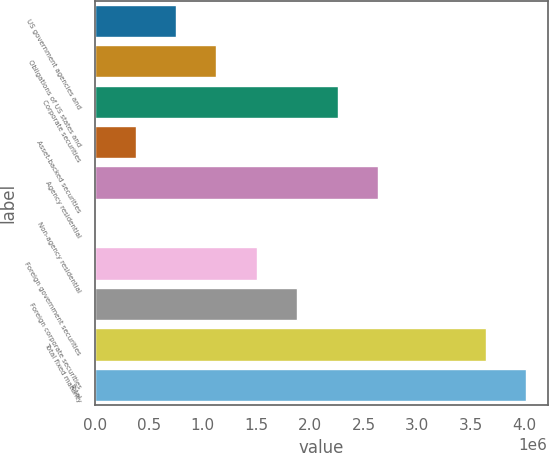<chart> <loc_0><loc_0><loc_500><loc_500><bar_chart><fcel>US government agencies and<fcel>Obligations of US states and<fcel>Corporate securities<fcel>Asset-backed securities<fcel>Agency residential<fcel>Non-agency residential<fcel>Foreign government securities<fcel>Foreign corporate securities<fcel>Total fixed maturity<fcel>Total<nl><fcel>754274<fcel>1.13053e+06<fcel>2.25931e+06<fcel>378016<fcel>2.63557e+06<fcel>1758<fcel>1.50679e+06<fcel>1.88305e+06<fcel>3.63731e+06<fcel>4.01357e+06<nl></chart> 